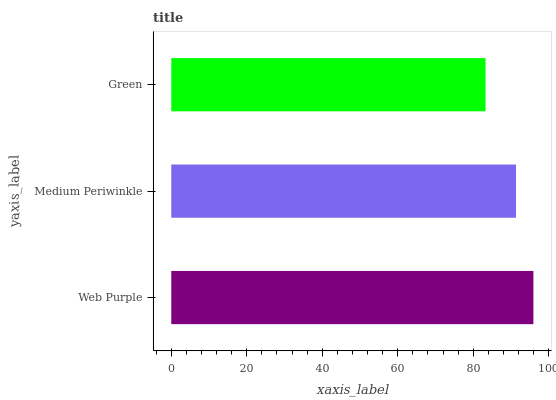Is Green the minimum?
Answer yes or no. Yes. Is Web Purple the maximum?
Answer yes or no. Yes. Is Medium Periwinkle the minimum?
Answer yes or no. No. Is Medium Periwinkle the maximum?
Answer yes or no. No. Is Web Purple greater than Medium Periwinkle?
Answer yes or no. Yes. Is Medium Periwinkle less than Web Purple?
Answer yes or no. Yes. Is Medium Periwinkle greater than Web Purple?
Answer yes or no. No. Is Web Purple less than Medium Periwinkle?
Answer yes or no. No. Is Medium Periwinkle the high median?
Answer yes or no. Yes. Is Medium Periwinkle the low median?
Answer yes or no. Yes. Is Green the high median?
Answer yes or no. No. Is Green the low median?
Answer yes or no. No. 